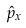Convert formula to latex. <formula><loc_0><loc_0><loc_500><loc_500>\hat { p } _ { x }</formula> 